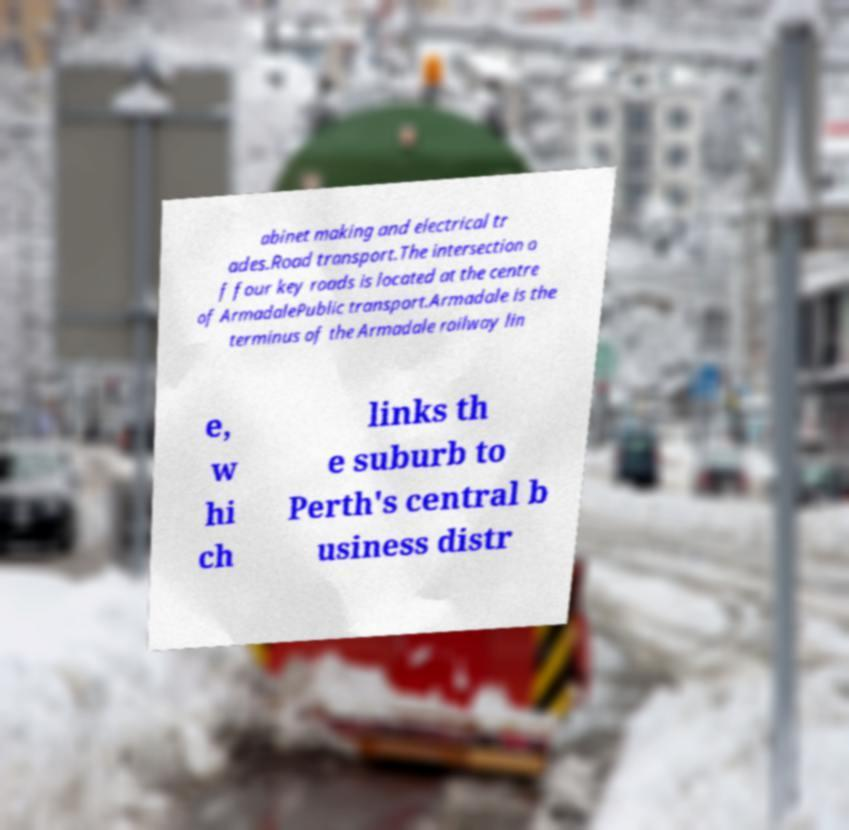Could you assist in decoding the text presented in this image and type it out clearly? abinet making and electrical tr ades.Road transport.The intersection o f four key roads is located at the centre of ArmadalePublic transport.Armadale is the terminus of the Armadale railway lin e, w hi ch links th e suburb to Perth's central b usiness distr 